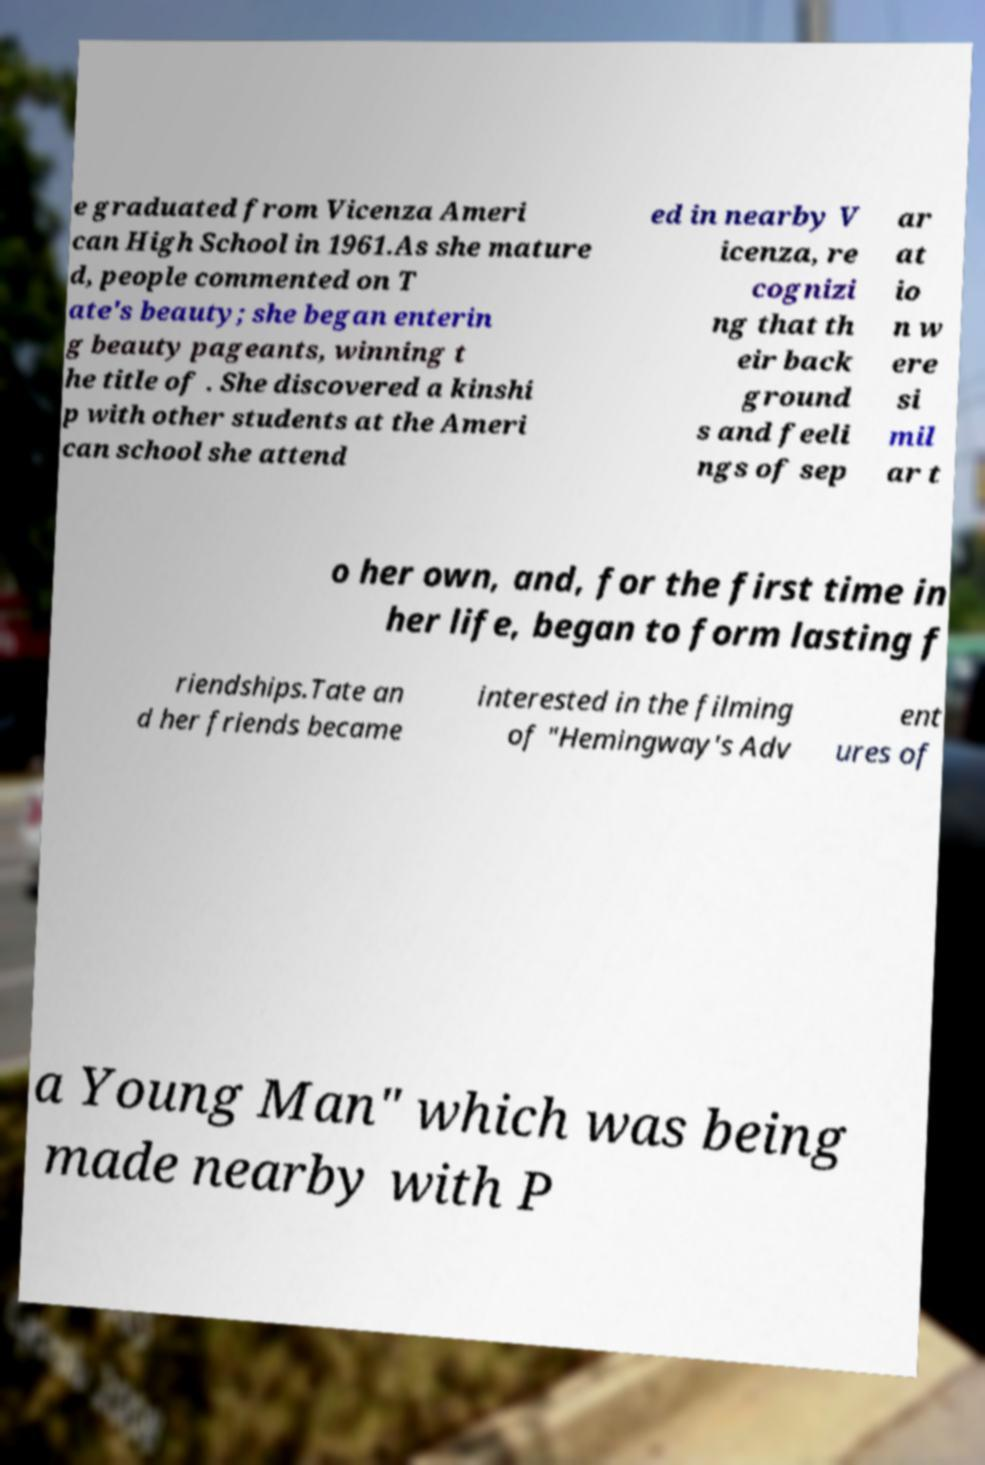Could you assist in decoding the text presented in this image and type it out clearly? e graduated from Vicenza Ameri can High School in 1961.As she mature d, people commented on T ate's beauty; she began enterin g beauty pageants, winning t he title of . She discovered a kinshi p with other students at the Ameri can school she attend ed in nearby V icenza, re cognizi ng that th eir back ground s and feeli ngs of sep ar at io n w ere si mil ar t o her own, and, for the first time in her life, began to form lasting f riendships.Tate an d her friends became interested in the filming of "Hemingway's Adv ent ures of a Young Man" which was being made nearby with P 